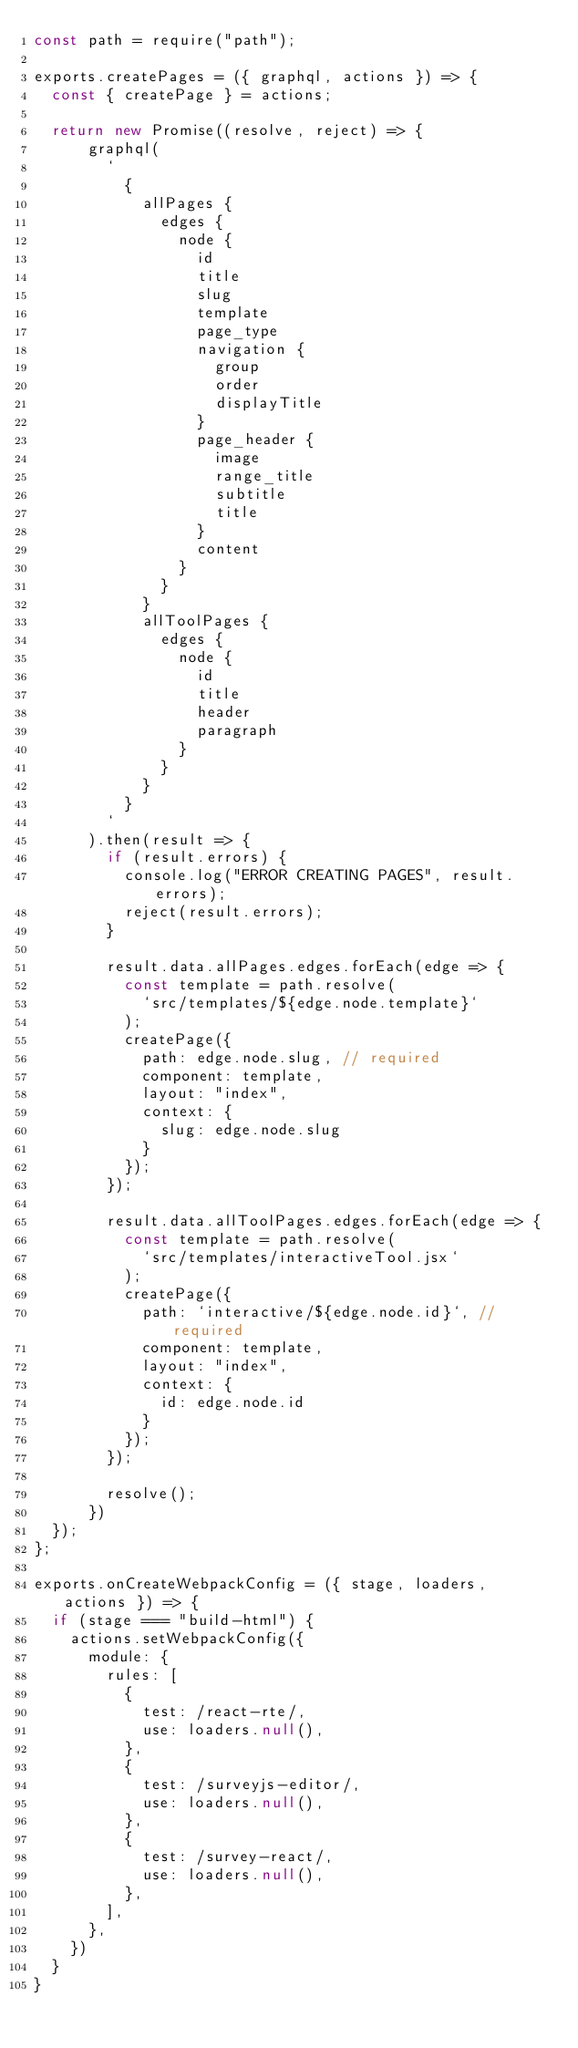Convert code to text. <code><loc_0><loc_0><loc_500><loc_500><_JavaScript_>const path = require("path");

exports.createPages = ({ graphql, actions }) => {
  const { createPage } = actions;

  return new Promise((resolve, reject) => {
      graphql(
        `
          {
            allPages {
              edges {
                node {
                  id
                  title
                  slug
                  template
                  page_type
                  navigation {
                    group
                    order
                    displayTitle
                  }
                  page_header {
                    image
                    range_title
                    subtitle
                    title
                  }
                  content
                }
              }
            }
            allToolPages {
              edges {
                node {
                  id
                  title
                  header
                  paragraph
                }
              }
            }
          }
        `
      ).then(result => {
        if (result.errors) {
          console.log("ERROR CREATING PAGES", result.errors);
          reject(result.errors);
        }

        result.data.allPages.edges.forEach(edge => {
          const template = path.resolve(
            `src/templates/${edge.node.template}`
          );
          createPage({
            path: edge.node.slug, // required
            component: template,
            layout: "index",
            context: {
              slug: edge.node.slug
            }
          });
        });

        result.data.allToolPages.edges.forEach(edge => {
          const template = path.resolve(
            `src/templates/interactiveTool.jsx`
          );
          createPage({
            path: `interactive/${edge.node.id}`, // required
            component: template,
            layout: "index",
            context: {
              id: edge.node.id
            }
          });
        });

        resolve();
      })
  });
};

exports.onCreateWebpackConfig = ({ stage, loaders, actions }) => {
  if (stage === "build-html") {
    actions.setWebpackConfig({
      module: {
        rules: [
          {
            test: /react-rte/,
            use: loaders.null(),
          },
          {
            test: /surveyjs-editor/,
            use: loaders.null(),
          },
          {
            test: /survey-react/,
            use: loaders.null(),
          },
        ],
      },
    })
  }
}</code> 